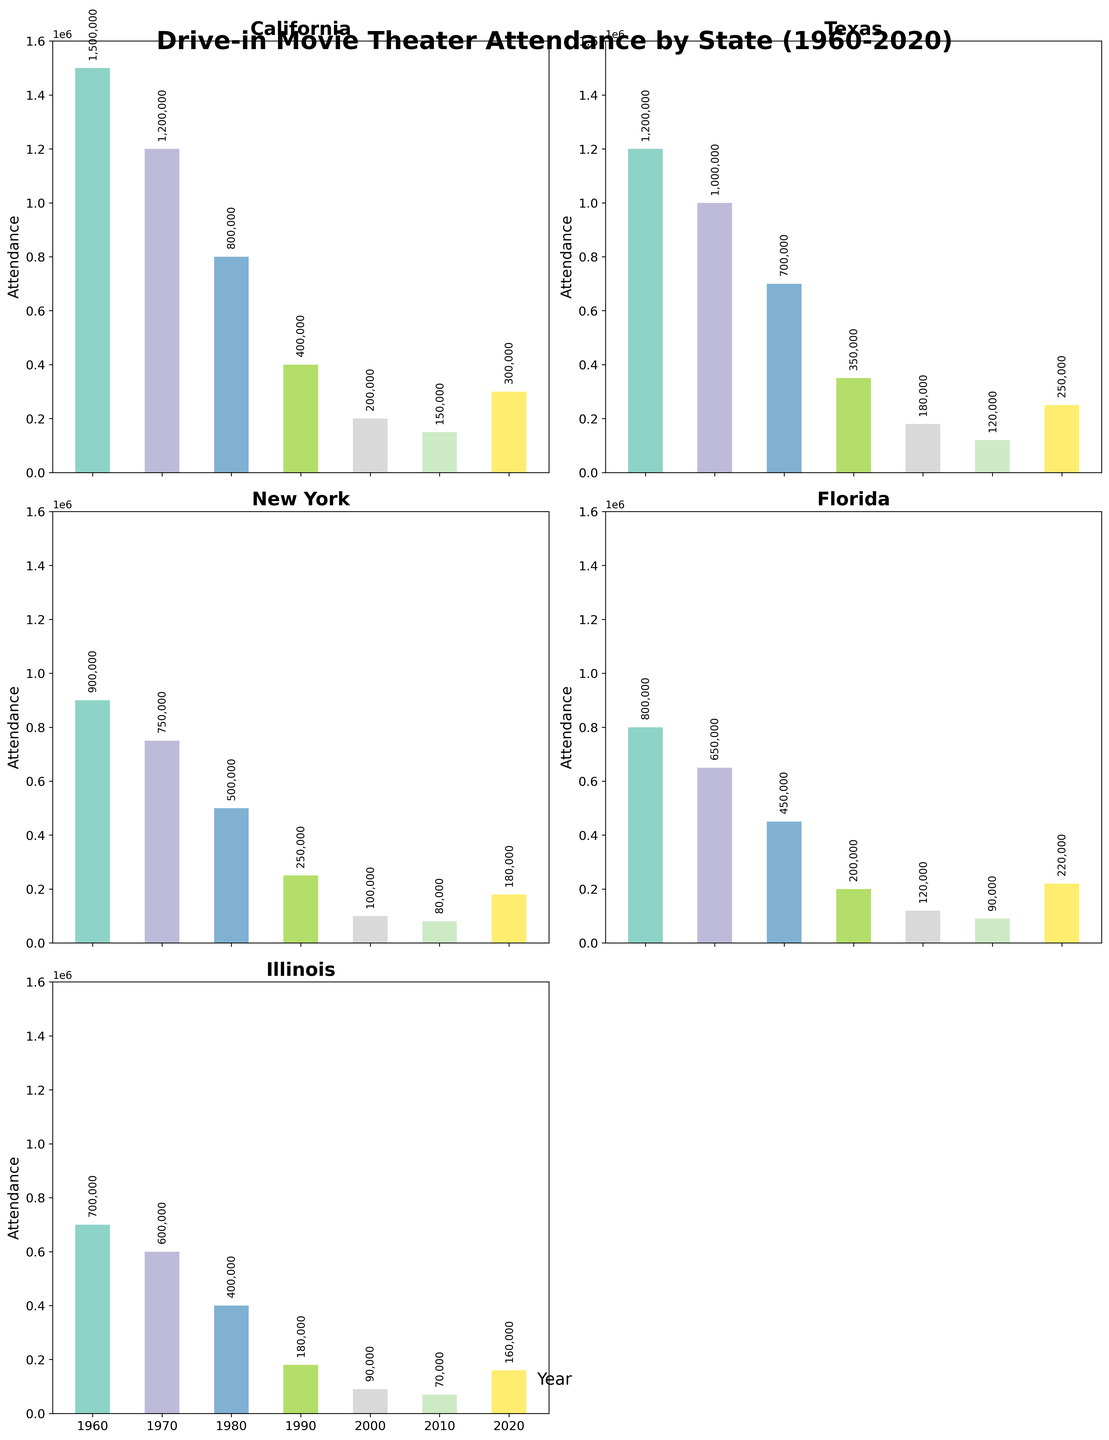Which state had the highest attendance in 1960? The bars show the attendance figures for each state. By visually inspecting the figure, California has the tallest bar in 1960, indicating the highest attendance.
Answer: California How did California's attendance change from 1960 to 2020? Locate California's bars for 1960 and 2020. In 1960, the attendance was 1,500,000 and in 2020 it was 300,000. The change is a decrease by 1,200,000.
Answer: Decreased by 1,200,000 What was the trend in attendance for Texas from 1960 to 2020? Observe the bars for Texas across the years. The graph shows a general downward trend from 1,200,000 in 1960, reaching 250,000 in 2020.
Answer: Downward trend Which state had the lowest attendance in 2000? Look at the bars of each state for the year 2000. New York has the shortest bar with an attendance of 100,000 in 2000.
Answer: New York Compare the attendance in 1980 between New York and Illinois. Which was higher? Compare the height of the bars for New York and Illinois in 1980. New York's bar represents 500,000 and Illinois' bar represents 400,000. New York had a higher attendance.
Answer: New York What was the average attendance in Florida between 1960 and 2020? Sum the attendance values for Florida from 1960 to 2020 (800,000 + 650,000 + 450,000 + 200,000 + 120,000 + 90,000 + 220,000) = 2,530,000 and divide by 7.
Answer: 361,428 By how much did Illinois' attendance drop from 1960 to 1990? Find the attendance for Illinois in 1960 (700,000) and 1990 (180,000). The drop is 700,000 - 180,000 = 520,000.
Answer: 520,000 What is the total attendance for all states in 2010? Add the attendance figures for all states in 2010 (150,000 + 120,000 + 80,000 + 90,000 + 70,000). The total is 510,000.
Answer: 510,000 Which year showed the first significant decline in attendance across all states? Review the change in heights of bars for each state across the years. 1970 shows a clear decline from 1960 across multiple states.
Answer: 1970 